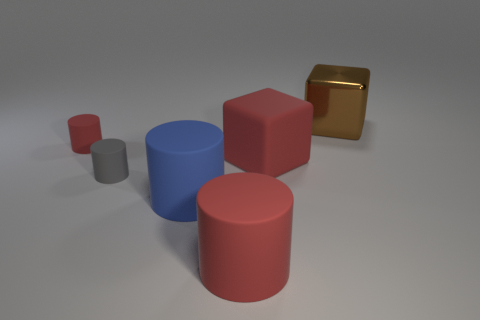How many other things are the same shape as the big brown metal thing?
Your answer should be compact. 1. There is a gray thing; are there any rubber cylinders to the left of it?
Make the answer very short. Yes. The metallic block has what color?
Give a very brief answer. Brown. Does the large shiny object have the same color as the cube on the left side of the brown block?
Offer a terse response. No. Is there a thing that has the same size as the blue cylinder?
Provide a short and direct response. Yes. There is a thing behind the small red object; what is its material?
Give a very brief answer. Metal. Are there an equal number of big red rubber blocks to the left of the big red block and matte things on the right side of the small gray rubber thing?
Your answer should be very brief. No. Does the red rubber cylinder that is in front of the tiny red rubber object have the same size as the block that is in front of the small red cylinder?
Keep it short and to the point. Yes. What number of rubber spheres have the same color as the rubber block?
Offer a terse response. 0. There is a small object that is the same color as the big matte block; what material is it?
Your response must be concise. Rubber. 